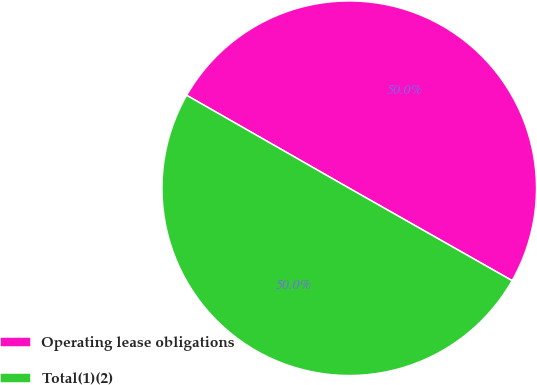Convert chart to OTSL. <chart><loc_0><loc_0><loc_500><loc_500><pie_chart><fcel>Operating lease obligations<fcel>Total(1)(2)<nl><fcel>49.95%<fcel>50.05%<nl></chart> 